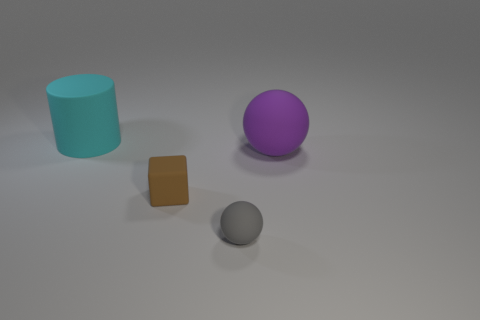There is a large sphere; what number of large spheres are on the right side of it?
Your response must be concise. 0. Is the color of the matte cylinder the same as the tiny sphere?
Your response must be concise. No. What shape is the cyan object that is made of the same material as the gray sphere?
Keep it short and to the point. Cylinder. Do the rubber object that is behind the large ball and the small brown thing have the same shape?
Your answer should be very brief. No. What number of purple objects are either matte things or tiny rubber cubes?
Your answer should be very brief. 1. Are there an equal number of tiny rubber spheres that are behind the cylinder and big objects that are on the left side of the tiny matte sphere?
Make the answer very short. No. There is a rubber object behind the big rubber object that is in front of the rubber object that is behind the big purple thing; what color is it?
Provide a succinct answer. Cyan. Are there any other things that are the same color as the big cylinder?
Offer a terse response. No. There is a matte ball left of the big purple sphere; how big is it?
Your answer should be compact. Small. What is the shape of the purple thing that is the same size as the cyan cylinder?
Your answer should be compact. Sphere. 